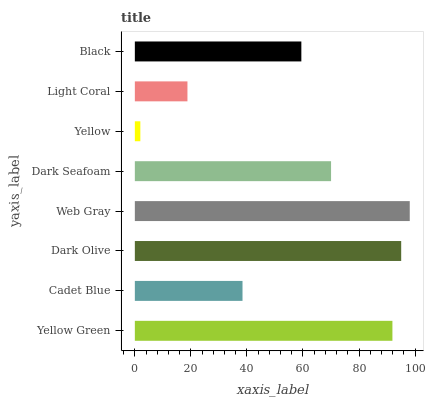Is Yellow the minimum?
Answer yes or no. Yes. Is Web Gray the maximum?
Answer yes or no. Yes. Is Cadet Blue the minimum?
Answer yes or no. No. Is Cadet Blue the maximum?
Answer yes or no. No. Is Yellow Green greater than Cadet Blue?
Answer yes or no. Yes. Is Cadet Blue less than Yellow Green?
Answer yes or no. Yes. Is Cadet Blue greater than Yellow Green?
Answer yes or no. No. Is Yellow Green less than Cadet Blue?
Answer yes or no. No. Is Dark Seafoam the high median?
Answer yes or no. Yes. Is Black the low median?
Answer yes or no. Yes. Is Web Gray the high median?
Answer yes or no. No. Is Yellow the low median?
Answer yes or no. No. 